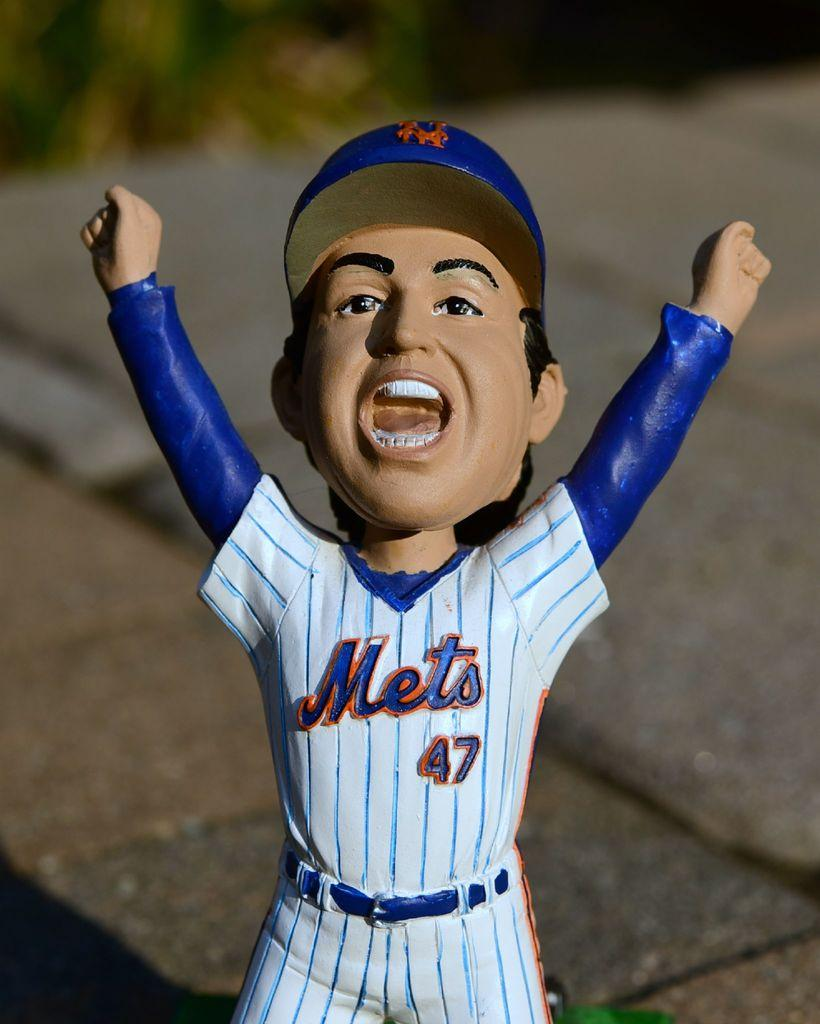<image>
Give a short and clear explanation of the subsequent image. A Mets player #47 bobble head figure is shown with his hands up and mouth open. 